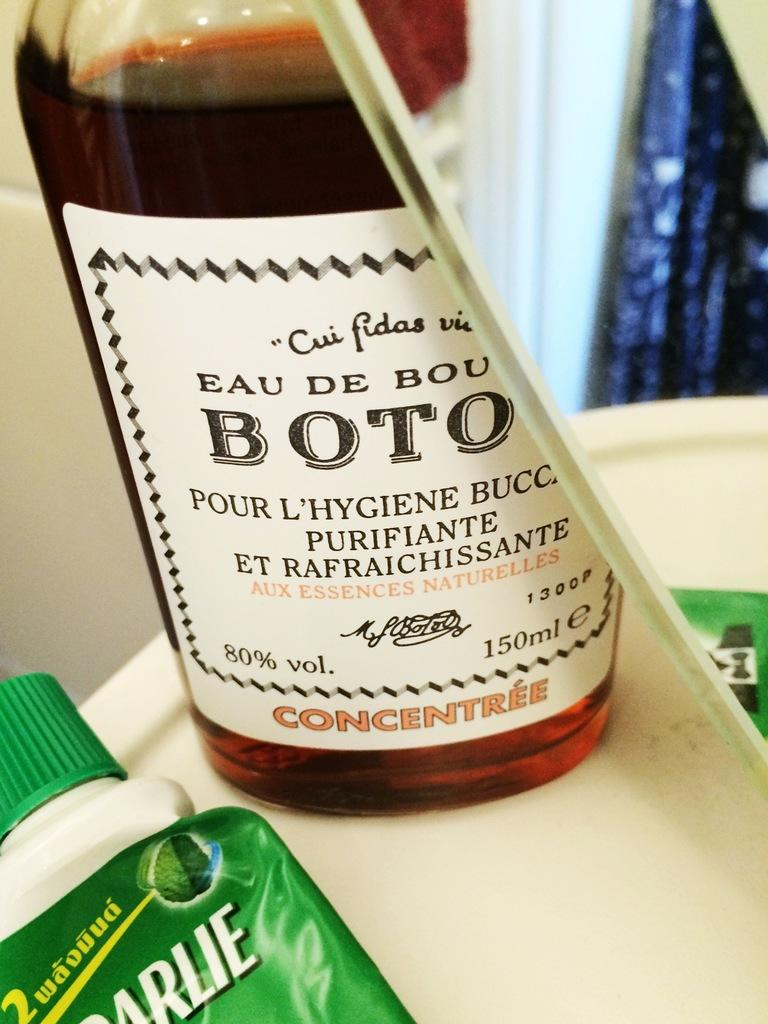<image>
Create a compact narrative representing the image presented. The bottle of alcohol that is presented has a volume size of 80%. 